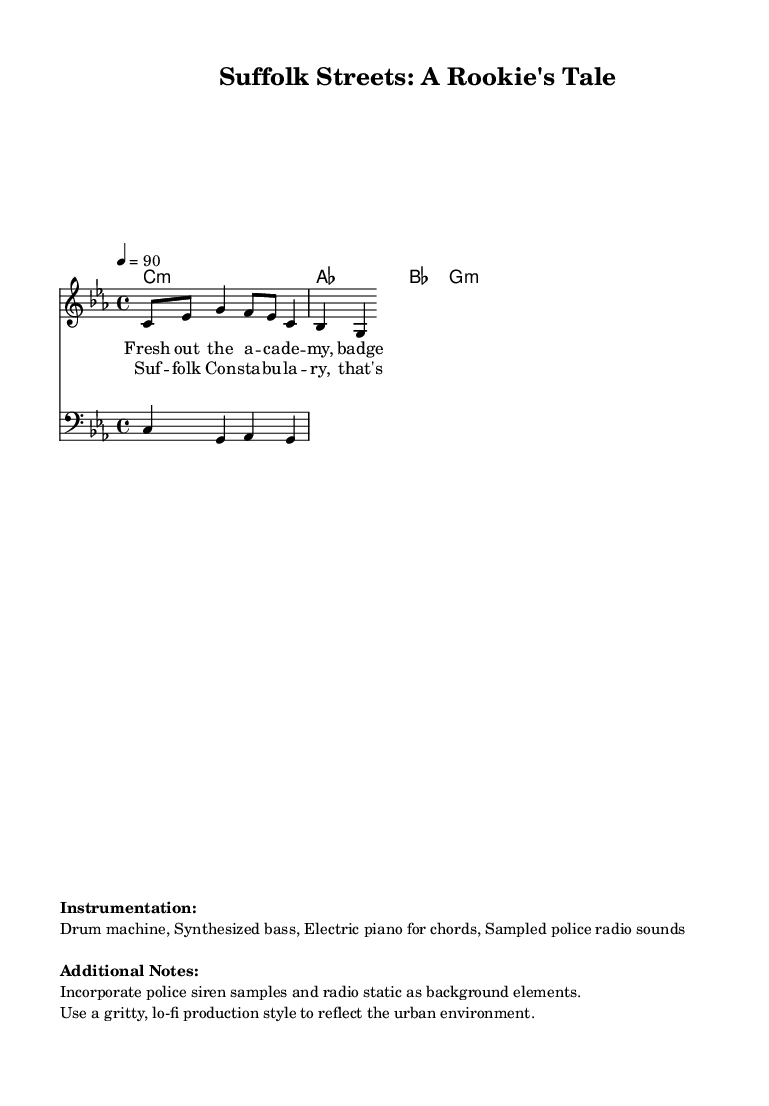What is the key signature of this music? The key signature is C minor, as indicated by the presence of three flats (B, E, and A) in the key signature section.
Answer: C minor What is the time signature of this piece? The time signature is 4/4, which implies there are four beats in each measure. This is noted at the beginning of the score.
Answer: 4/4 What is the tempo marking for this piece? The tempo marking is 90 beats per minute, specified as 4 = 90 at the beginning of the score.
Answer: 90 What instruments are used in the music? The instruments listed are a drum machine, synthesized bass, and electric piano for chords, which are specified in the instrumentation section.
Answer: Drum machine, Synthesized bass, Electric piano How many measures are there in the verse? The verse contains two measures, as indicated by the lyrics and their alignment with the staff lines.
Answer: 2 What genre does this music belong to? The genre of the music is Hip Hop, as inferred from the title "Suffolk Streets: A Rookie's Tale" and the context of the lyrics.
Answer: Hip Hop What motif is incorporated in the background? Police siren samples and radio static are incorporated as background elements, as noted in the additional notes section of the score.
Answer: Police siren samples 